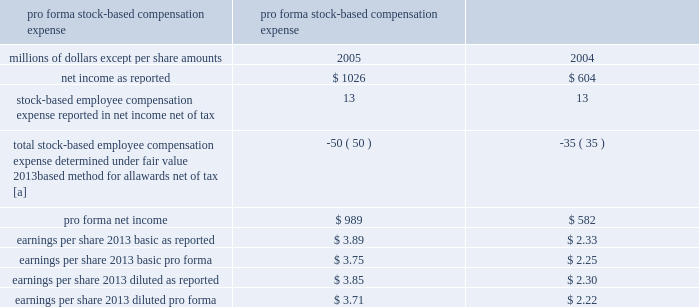Stock-based compensation 2013 we have several stock-based compensation plans under which employees and non-employee directors receive stock options , nonvested retention shares , and nonvested stock units .
We refer to the nonvested shares and stock units collectively as 201cretention awards 201d .
We issue treasury shares to cover option exercises and stock unit vestings , while new shares are issued when retention shares vest .
We adopted fasb statement no .
123 ( r ) , share-based payment ( fas 123 ( r ) ) , on january 1 , 2006 .
Fas 123 ( r ) requires us to measure and recognize compensation expense for all stock-based awards made to employees and directors , including stock options .
Compensation expense is based on the calculated fair value of the awards as measured at the grant date and is expensed ratably over the service period of the awards ( generally the vesting period ) .
The fair value of retention awards is the stock price on the date of grant , while the fair value of stock options is determined by using the black-scholes option pricing model .
We elected to use the modified prospective transition method as permitted by fas 123 ( r ) and did not restate financial results for prior periods .
We did not make an adjustment for the cumulative effect of these estimated forfeitures , as the impact was not material .
As a result of the adoption of fas 123 ( r ) , we recognized expense for stock options in 2006 , in addition to retention awards , which were expensed prior to 2006 .
Stock-based compensation expense for the year ended december 31 , 2006 was $ 22 million , after tax , or $ 0.08 per basic and diluted share .
This includes $ 9 million for stock options and $ 13 million for retention awards for 2006 .
Before taxes , stock-based compensation expense included $ 14 million for stock options and $ 21 million for retention awards for 2006 .
We recorded $ 29 million of excess tax benefits as an inflow of financing activities in the consolidated statement of cash flows for the year ended december 31 , 2006 .
Prior to the adoption of fas 123 ( r ) , we applied the recognition and measurement principles of accounting principles board opinion no .
25 , accounting for stock issued to employees , and related interpretations .
No stock- based employee compensation expense related to stock option grants was reflected in net income , as all options granted under those plans had a grant price equal to the market value of our common stock on the date of grant .
Stock-based compensation expense related to retention shares , stock units , and other incentive plans was reflected in net income .
The table details the effect on net income and earnings per share had compensation expense for all of our stock-based awards , including stock options , been recorded in the years ended december 31 , 2005 and 2004 based on the fair value method under fasb statement no .
123 , accounting for stock-based compensation .
Pro forma stock-based compensation expense year ended december 31 , millions of dollars , except per share amounts 2005 2004 .
[a] stock options for executives granted in 2003 and 2002 included a reload feature .
This reload feature allowed executives to exercise their options using shares of union pacific corporation common stock that they already owned and obtain a new grant of options in the amount of the shares used for exercise plus any shares withheld for tax purposes .
The reload feature of these option grants could only be exercised if the .
What was the percentage of the increase in the basic earnings per share 2013 as reported from 2005 to 2006? 
Computations: ((3.89 - 2.33) / 2.33)
Answer: 0.66953. Stock-based compensation 2013 we have several stock-based compensation plans under which employees and non-employee directors receive stock options , nonvested retention shares , and nonvested stock units .
We refer to the nonvested shares and stock units collectively as 201cretention awards 201d .
We issue treasury shares to cover option exercises and stock unit vestings , while new shares are issued when retention shares vest .
We adopted fasb statement no .
123 ( r ) , share-based payment ( fas 123 ( r ) ) , on january 1 , 2006 .
Fas 123 ( r ) requires us to measure and recognize compensation expense for all stock-based awards made to employees and directors , including stock options .
Compensation expense is based on the calculated fair value of the awards as measured at the grant date and is expensed ratably over the service period of the awards ( generally the vesting period ) .
The fair value of retention awards is the stock price on the date of grant , while the fair value of stock options is determined by using the black-scholes option pricing model .
We elected to use the modified prospective transition method as permitted by fas 123 ( r ) and did not restate financial results for prior periods .
We did not make an adjustment for the cumulative effect of these estimated forfeitures , as the impact was not material .
As a result of the adoption of fas 123 ( r ) , we recognized expense for stock options in 2006 , in addition to retention awards , which were expensed prior to 2006 .
Stock-based compensation expense for the year ended december 31 , 2006 was $ 22 million , after tax , or $ 0.08 per basic and diluted share .
This includes $ 9 million for stock options and $ 13 million for retention awards for 2006 .
Before taxes , stock-based compensation expense included $ 14 million for stock options and $ 21 million for retention awards for 2006 .
We recorded $ 29 million of excess tax benefits as an inflow of financing activities in the consolidated statement of cash flows for the year ended december 31 , 2006 .
Prior to the adoption of fas 123 ( r ) , we applied the recognition and measurement principles of accounting principles board opinion no .
25 , accounting for stock issued to employees , and related interpretations .
No stock- based employee compensation expense related to stock option grants was reflected in net income , as all options granted under those plans had a grant price equal to the market value of our common stock on the date of grant .
Stock-based compensation expense related to retention shares , stock units , and other incentive plans was reflected in net income .
The table details the effect on net income and earnings per share had compensation expense for all of our stock-based awards , including stock options , been recorded in the years ended december 31 , 2005 and 2004 based on the fair value method under fasb statement no .
123 , accounting for stock-based compensation .
Pro forma stock-based compensation expense year ended december 31 , millions of dollars , except per share amounts 2005 2004 .
[a] stock options for executives granted in 2003 and 2002 included a reload feature .
This reload feature allowed executives to exercise their options using shares of union pacific corporation common stock that they already owned and obtain a new grant of options in the amount of the shares used for exercise plus any shares withheld for tax purposes .
The reload feature of these option grants could only be exercised if the .
What was the percentage difference of earnings per share 2013 basic pro forma compared to earnings per share 2013 diluted pro forma in 2005? 
Computations: ((3.75 - 3.71) / 3.75)
Answer: 0.01067. 